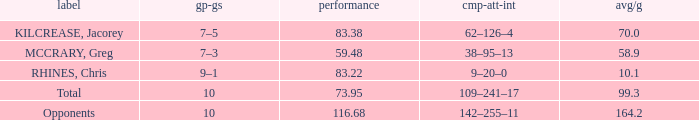What is the avg/g of Rhines, Chris, who has an effic greater than 73.95? 10.1. 